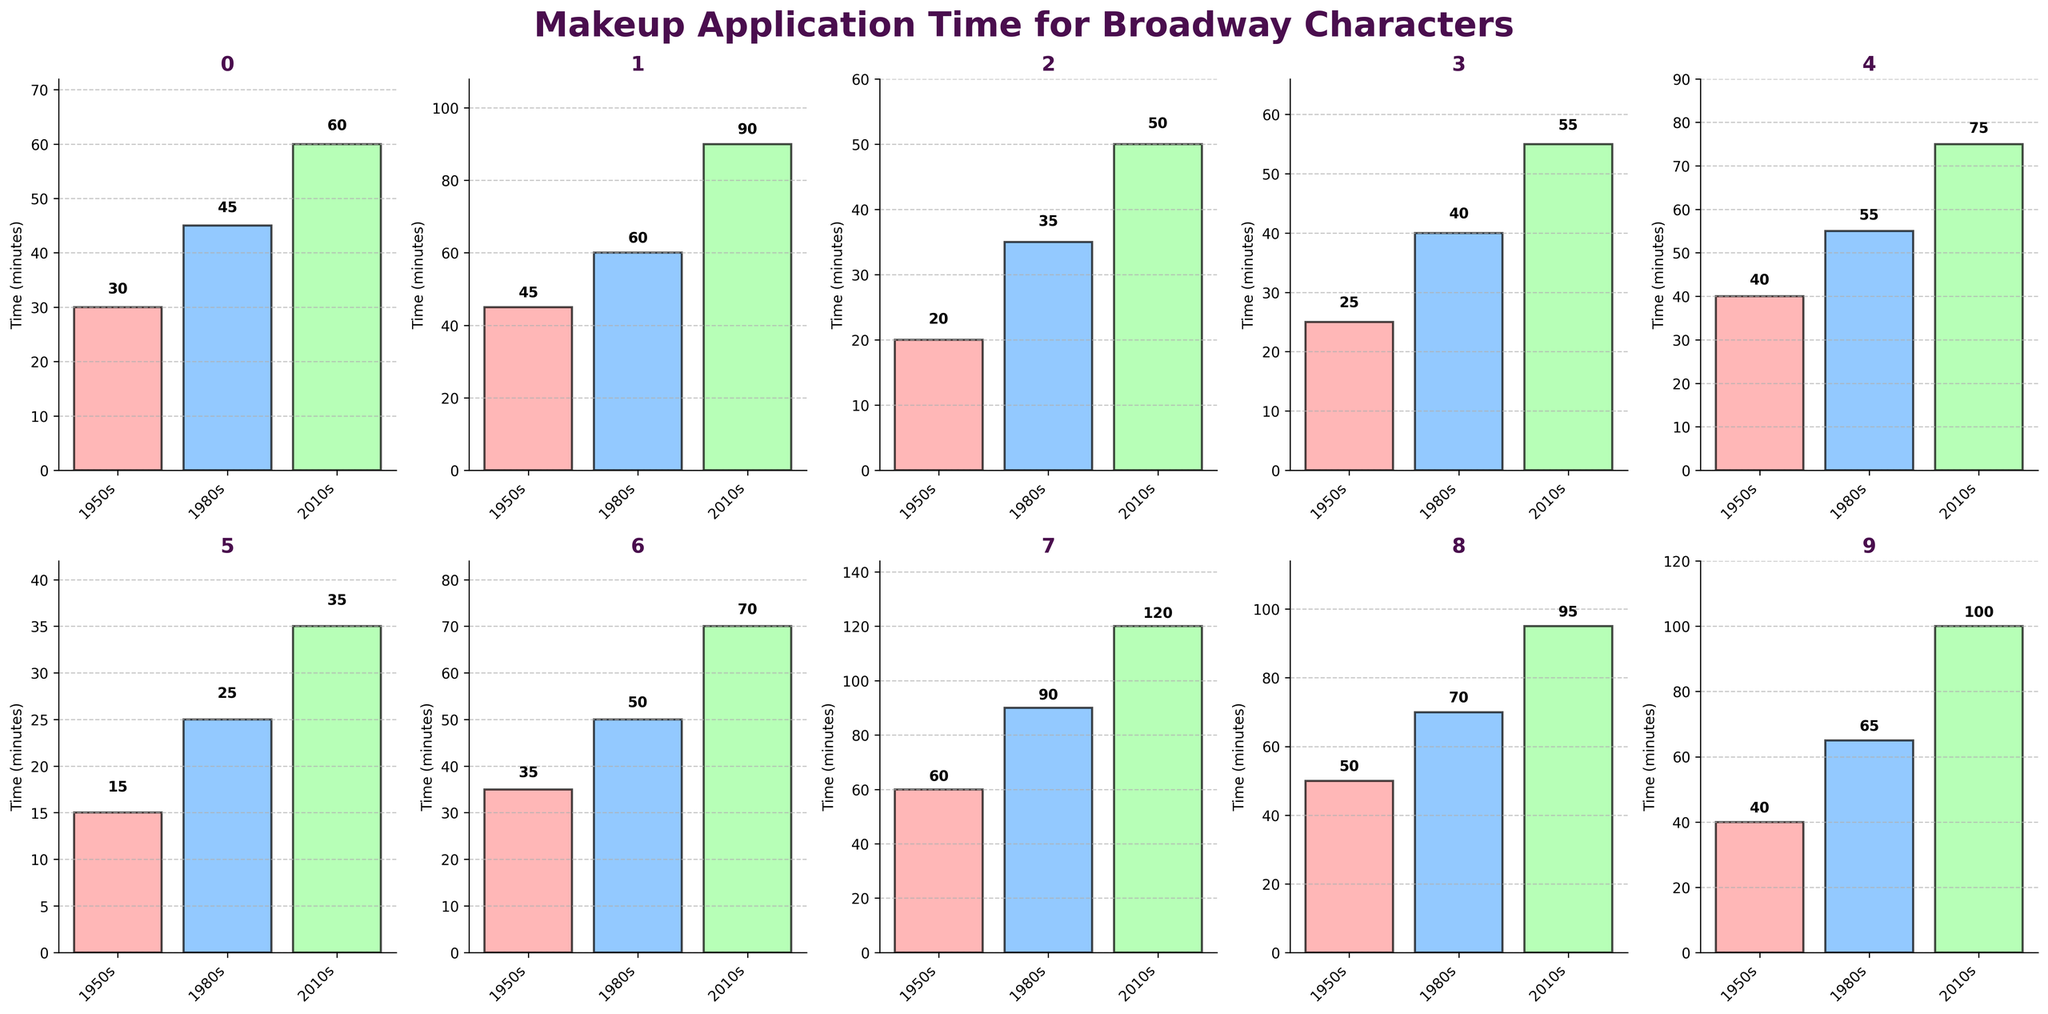What is the title of the figure? The title of a figure is usually placed at the top and is meant to provide a summary of what the figure is about. Here, it's given in the code snippet as 'Makeup Application Time for Broadway Characters'.
Answer: Makeup Application Time for Broadway Characters Which character type took the longest makeup time in the 2010s? To find the answer, look at the highest bar in the 2010s category for each subplot. The Fantastical Creature subplot has the highest bar, indicating 120 minutes.
Answer: Fantastical Creature Compare the makeup times for the Ingenue character type across all three eras. Look at the subplot titled 'Ingenue' and compare the heights of the bars corresponding to the 1950s, 1980s, and 2010s. The times are 30 minutes, 45 minutes, and 60 minutes, respectively.
Answer: 30, 45, 60 What's the difference in makeup time for the Villain character type between the 1950s and the 2010s? Check the subplot titled 'Villain' and find the bar heights for the 1950s and the 2010s. The times are 45 minutes and 90 minutes. Subtract 45 from 90.
Answer: 45 minutes Which era shows the least variance in makeup application times across different character types? Calculate the variance for each era by visually inspecting the range between the highest and lowest values for each subplot in that era. The 1950s appear to have the smallest range between 15 (Chorus Member) and 60 (Fantastical Creature), showing the least variance.
Answer: 1950s What is the total makeup application time for all character types in the 1980s? Sum the bar heights for all subplots in the 1980s category. The times are 45 + 60 + 35 + 40 + 55 + 25 + 50 + 90 + 70 + 65 = 535.
Answer: 535 minutes How do the makeup application times for the Comedic Relief and Leading Man character types compare in the 1980s? Look at the subplots for Comedic Relief and Leading Man and compare the heights of the bars in the 1980s. Comedic Relief is 35 minutes and Leading Man is 40 minutes.
Answer: Leading Man is longer by 5 minutes What is the average makeup application time for the Diva character type across all eras? Find the bar heights for the Diva subplot in the 1950s, 1980s, and 2010s. The times are 40, 55, and 75 minutes. Calculate the average: (40 + 55 + 75) / 3 = 170 / 3 = 56.67.
Answer: 56.67 minutes Which character type has the smallest increase in makeup time from the 1950s to the 1980s? Check the increase in makeup time for each character type by looking at the difference in bar heights from the 1950s to the 1980s. Elderly Character has an increase from 35 to 50 minutes, which is the smallest increase of 15 minutes.
Answer: Elderly Character 